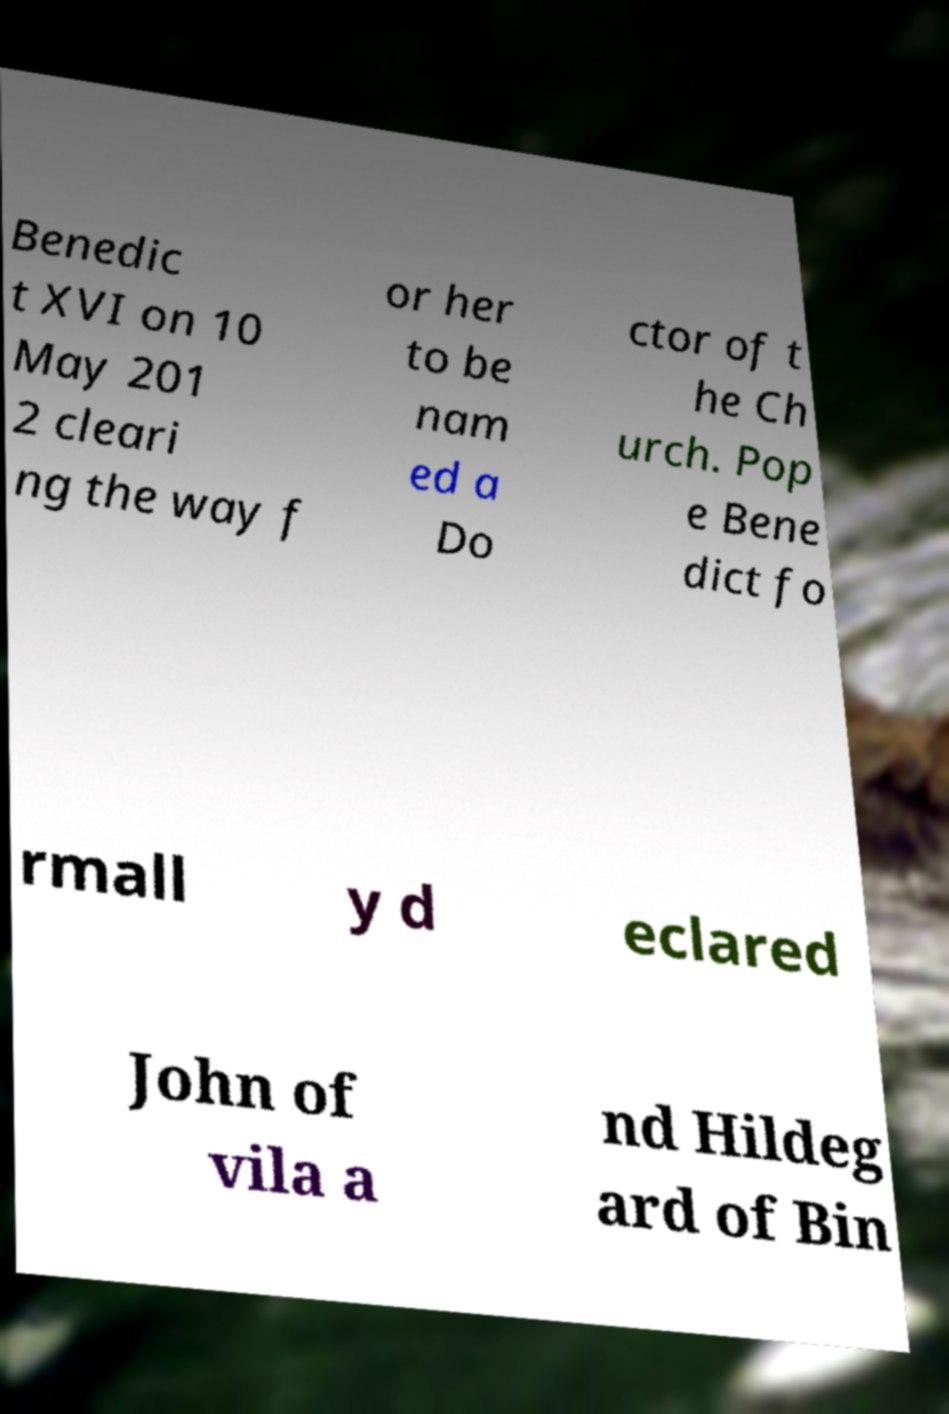I need the written content from this picture converted into text. Can you do that? Benedic t XVI on 10 May 201 2 cleari ng the way f or her to be nam ed a Do ctor of t he Ch urch. Pop e Bene dict fo rmall y d eclared John of vila a nd Hildeg ard of Bin 